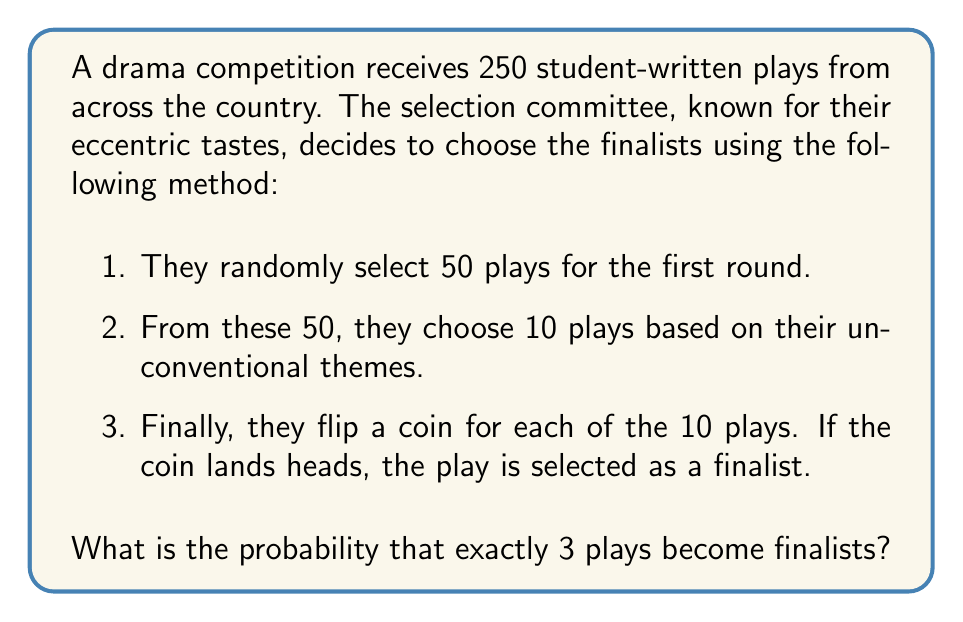Solve this math problem. Let's break this down step-by-step:

1) First, we need to recognize that this is a binomial probability problem. We have 10 independent trials (coin flips), each with a probability of success (heads) of 0.5.

2) We want to find the probability of exactly 3 successes out of 10 trials.

3) The binomial probability formula is:

   $$P(X = k) = \binom{n}{k} p^k (1-p)^{n-k}$$

   Where:
   $n$ = number of trials
   $k$ = number of successes
   $p$ = probability of success on each trial

4) In this case:
   $n = 10$
   $k = 3$
   $p = 0.5$

5) Let's calculate:

   $$P(X = 3) = \binom{10}{3} (0.5)^3 (1-0.5)^{10-3}$$

6) Expand this:

   $$P(X = 3) = \binom{10}{3} (0.5)^3 (0.5)^7$$

7) Calculate the combination:

   $$\binom{10}{3} = \frac{10!}{3!(10-3)!} = \frac{10!}{3!7!} = 120$$

8) Now our equation looks like:

   $$P(X = 3) = 120 \cdot (0.5)^3 \cdot (0.5)^7 = 120 \cdot (0.5)^{10}$$

9) Simplify:

   $$P(X = 3) = 120 \cdot \frac{1}{1024} = \frac{120}{1024} = \frac{15}{128} \approx 0.1172$$
Answer: $\frac{15}{128}$ 